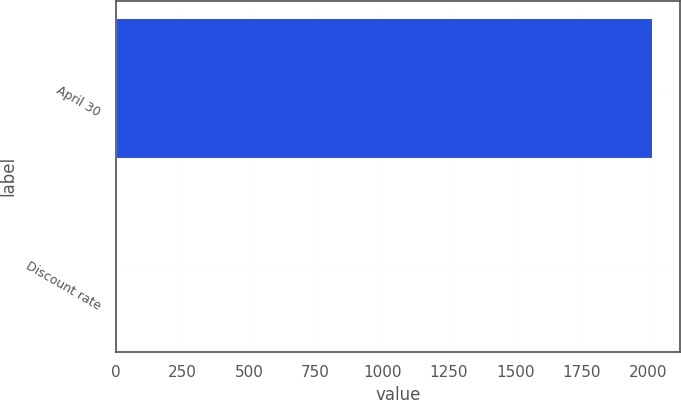Convert chart to OTSL. <chart><loc_0><loc_0><loc_500><loc_500><bar_chart><fcel>April 30<fcel>Discount rate<nl><fcel>2018<fcel>4.17<nl></chart> 